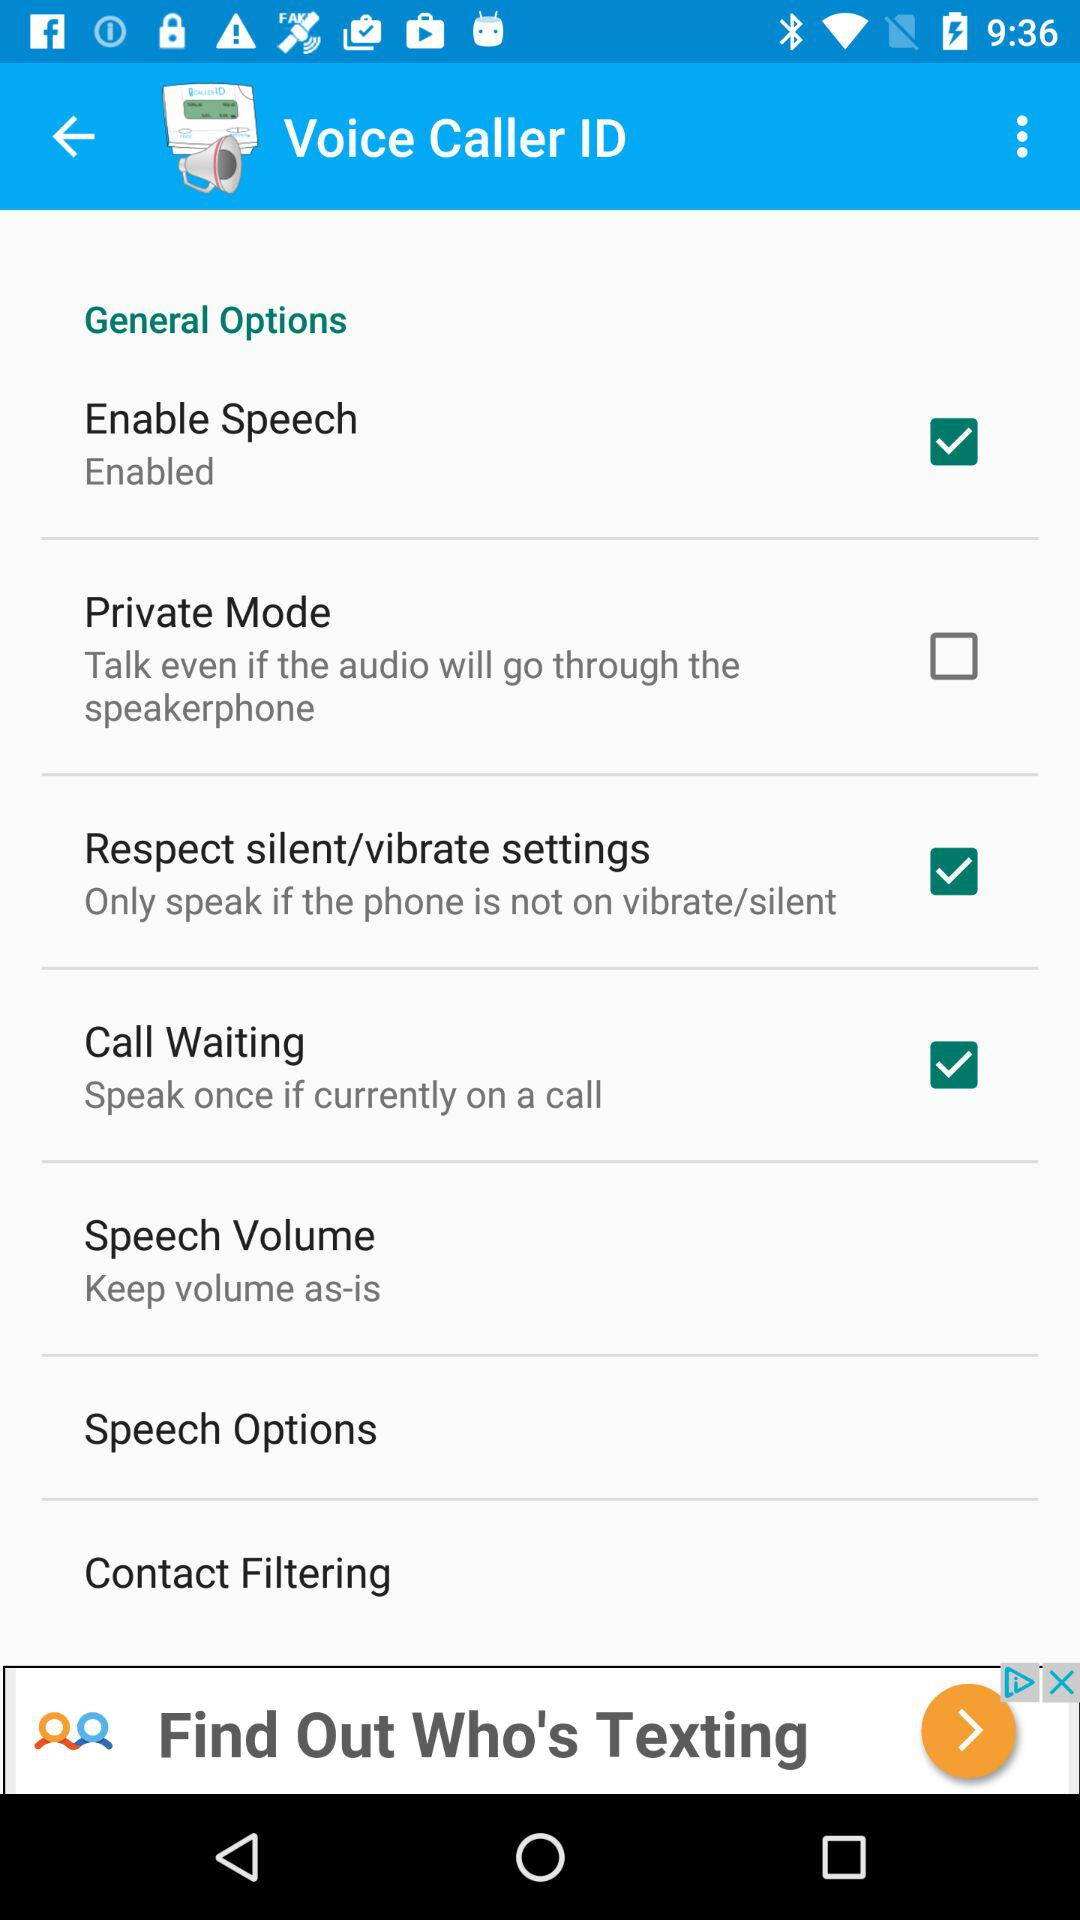Which speech options are available?
When the provided information is insufficient, respond with <no answer>. <no answer> 